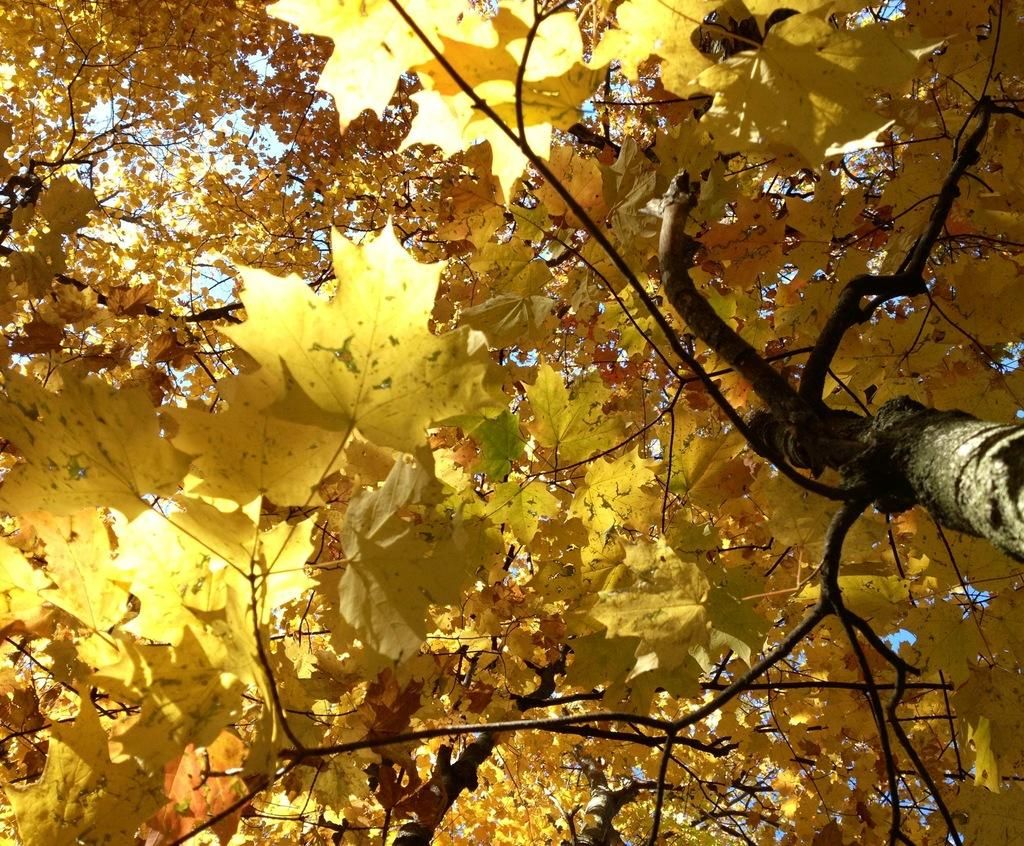Where was the picture taken? The picture was clicked outside. What can be seen in the foreground of the image? There is a tree in the foreground of the image. What is visible in the background of the image? The sky is visible in the background of the image. Can you see any squirrels or kites in the image? There are no squirrels or kites present in the image. 